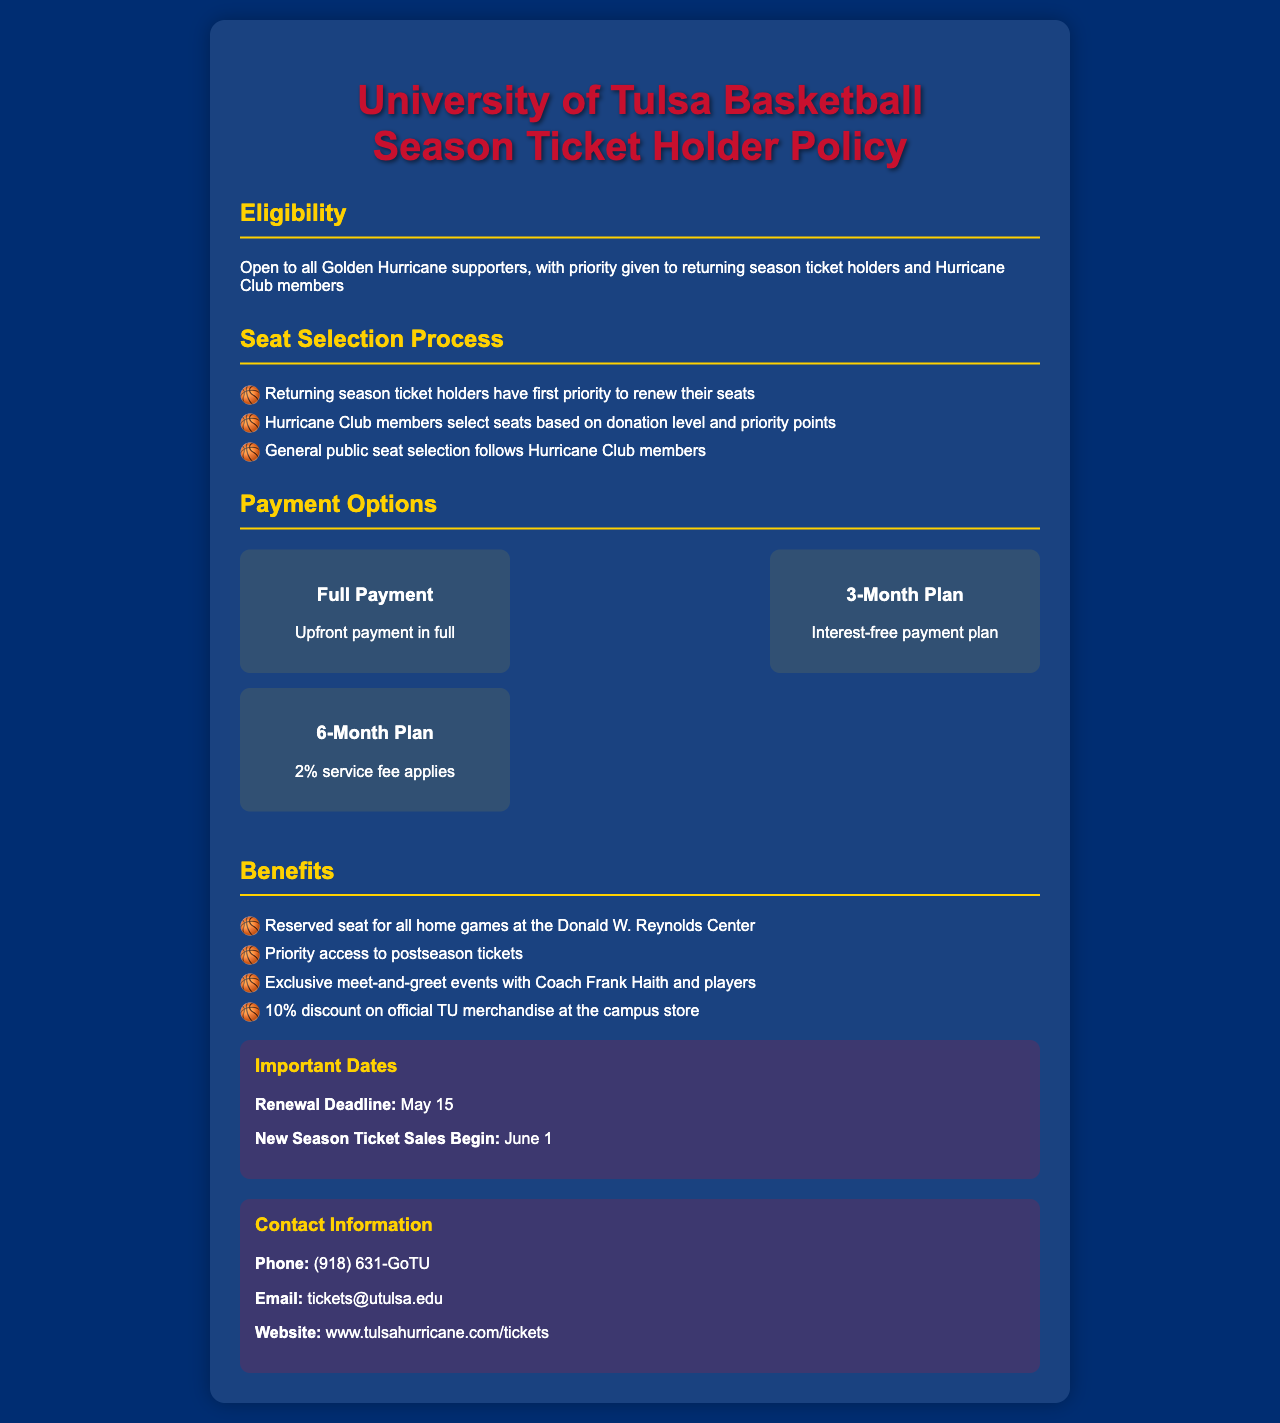what is the renewal deadline? The renewal deadline date is specifically stated in the document under important dates.
Answer: May 15 who has first priority to renew their seats? The document explicitly mentions that returning season ticket holders have the first priority.
Answer: Returning season ticket holders what is the service fee for the 6-month payment plan? The document lists the terms for payment plans, specifically mentioning a service fee for the 6-month plan.
Answer: 2% service fee what benefits do season ticket holders receive? The document lists multiple benefits for season ticket holders, focusing on exclusive offers and access.
Answer: Reserved seat for all home games at the Donald W. Reynolds Center when do new season ticket sales begin? This date is provided in the important dates section of the document.
Answer: June 1 how many payment options are available? The document outlines a section on payment options, enumerating the different choices.
Answer: 3 what is the email address for contacting about tickets? The contact information section provides specific details on how to reach out for ticket inquiries.
Answer: tickets@utulsa.edu which group gets priority seat selection after Hurricane Club members? The document describes the order of seat selection for various groups involved.
Answer: General public 